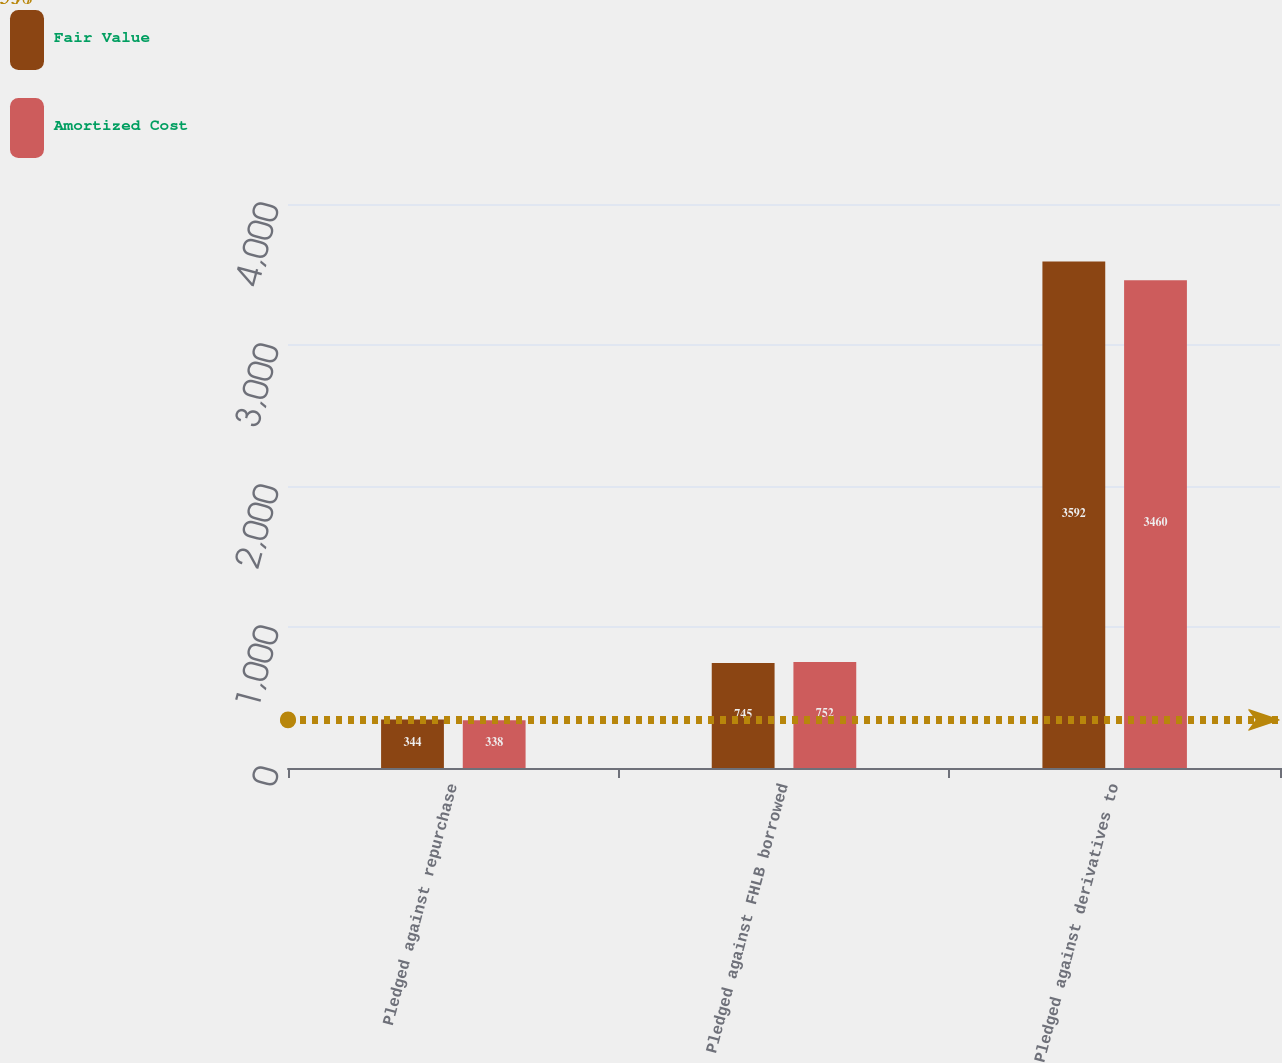<chart> <loc_0><loc_0><loc_500><loc_500><stacked_bar_chart><ecel><fcel>Pledged against repurchase<fcel>Pledged against FHLB borrowed<fcel>Pledged against derivatives to<nl><fcel>Fair Value<fcel>344<fcel>745<fcel>3592<nl><fcel>Amortized Cost<fcel>338<fcel>752<fcel>3460<nl></chart> 